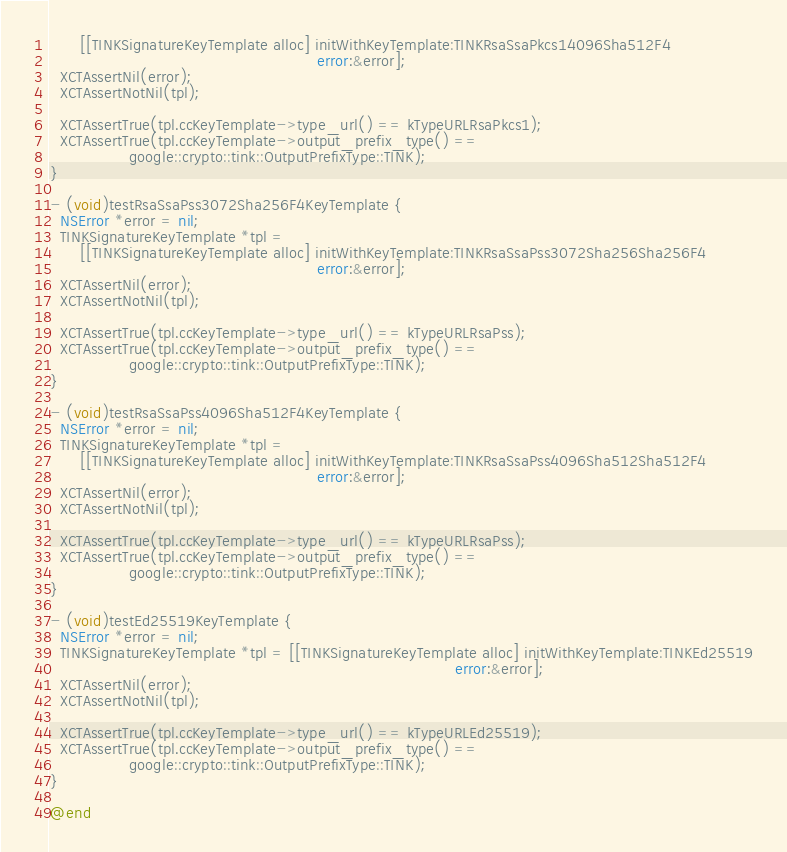Convert code to text. <code><loc_0><loc_0><loc_500><loc_500><_ObjectiveC_>      [[TINKSignatureKeyTemplate alloc] initWithKeyTemplate:TINKRsaSsaPkcs14096Sha512F4
                                                      error:&error];
  XCTAssertNil(error);
  XCTAssertNotNil(tpl);

  XCTAssertTrue(tpl.ccKeyTemplate->type_url() == kTypeURLRsaPkcs1);
  XCTAssertTrue(tpl.ccKeyTemplate->output_prefix_type() ==
                google::crypto::tink::OutputPrefixType::TINK);
}

- (void)testRsaSsaPss3072Sha256F4KeyTemplate {
  NSError *error = nil;
  TINKSignatureKeyTemplate *tpl =
      [[TINKSignatureKeyTemplate alloc] initWithKeyTemplate:TINKRsaSsaPss3072Sha256Sha256F4
                                                      error:&error];
  XCTAssertNil(error);
  XCTAssertNotNil(tpl);

  XCTAssertTrue(tpl.ccKeyTemplate->type_url() == kTypeURLRsaPss);
  XCTAssertTrue(tpl.ccKeyTemplate->output_prefix_type() ==
                google::crypto::tink::OutputPrefixType::TINK);
}

- (void)testRsaSsaPss4096Sha512F4KeyTemplate {
  NSError *error = nil;
  TINKSignatureKeyTemplate *tpl =
      [[TINKSignatureKeyTemplate alloc] initWithKeyTemplate:TINKRsaSsaPss4096Sha512Sha512F4
                                                      error:&error];
  XCTAssertNil(error);
  XCTAssertNotNil(tpl);

  XCTAssertTrue(tpl.ccKeyTemplate->type_url() == kTypeURLRsaPss);
  XCTAssertTrue(tpl.ccKeyTemplate->output_prefix_type() ==
                google::crypto::tink::OutputPrefixType::TINK);
}

- (void)testEd25519KeyTemplate {
  NSError *error = nil;
  TINKSignatureKeyTemplate *tpl = [[TINKSignatureKeyTemplate alloc] initWithKeyTemplate:TINKEd25519
                                                                                  error:&error];
  XCTAssertNil(error);
  XCTAssertNotNil(tpl);

  XCTAssertTrue(tpl.ccKeyTemplate->type_url() == kTypeURLEd25519);
  XCTAssertTrue(tpl.ccKeyTemplate->output_prefix_type() ==
                google::crypto::tink::OutputPrefixType::TINK);
}

@end
</code> 